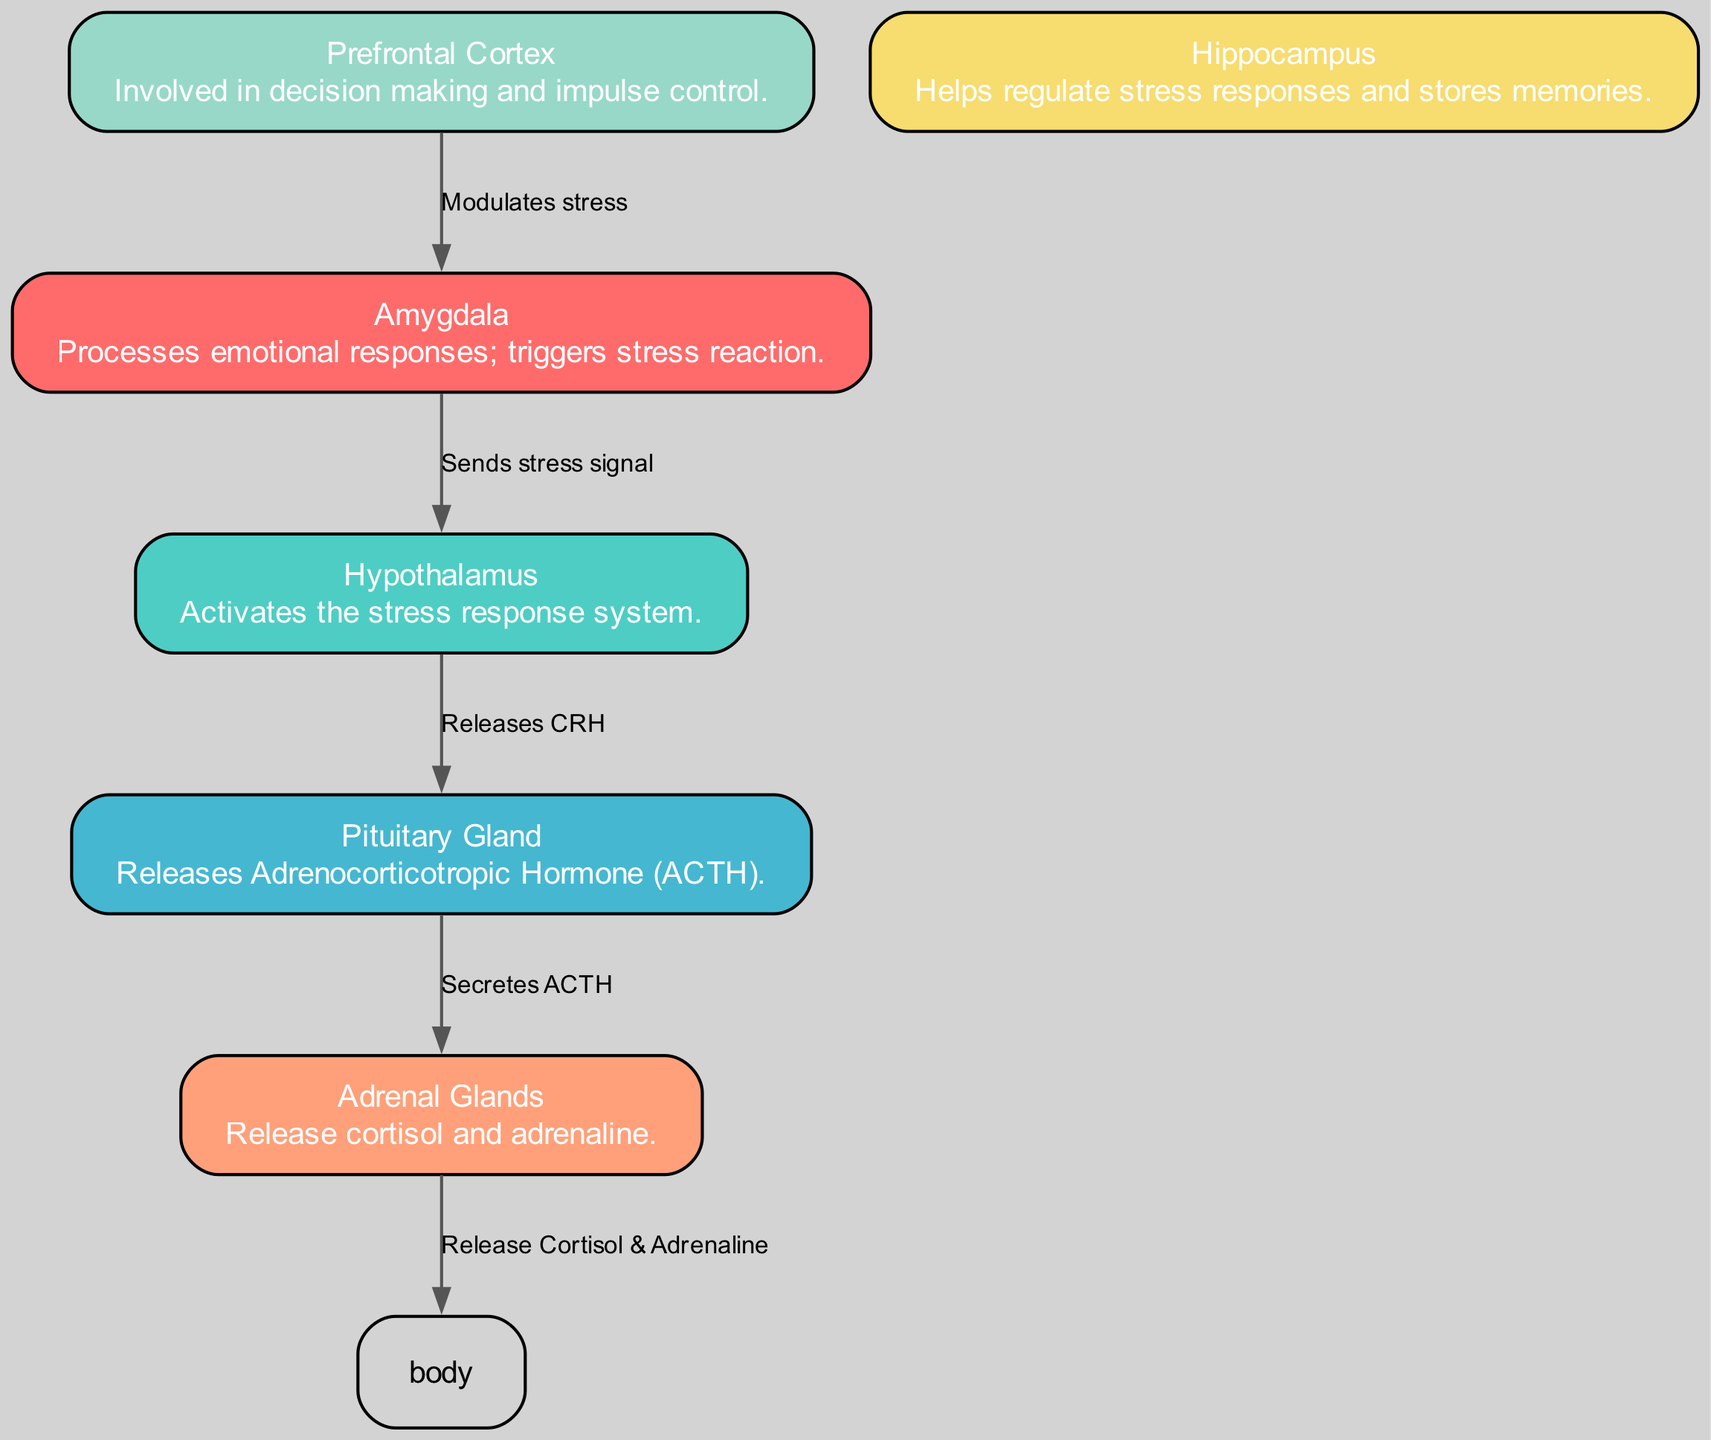What are the main brain regions involved in the stress response? The diagram lists six nodes representing brain regions: Amygdala, Hypothalamus, Pituitary Gland, Adrenal Glands, Prefrontal Cortex, and Hippocampus. These are clearly labeled in the diagram.
Answer: Amygdala, Hypothalamus, Pituitary Gland, Adrenal Glands, Prefrontal Cortex, Hippocampus Which node sends the stress signal? The edge labeled "Sends stress signal" connects the Amygdala to the Hypothalamus, indicating that the Amygdala is responsible for sending the stress signal.
Answer: Amygdala How many edges are present in the diagram? Counting the various connections (or edges) in the diagram, we find that there are five distinct edges linking the nodes together.
Answer: 5 What hormone is released by the Pituitary Gland? The label connected to the Pituitary Gland specifies that it releases Adrenocorticotropic Hormone (ACTH), making this information clear within the diagram.
Answer: Adrenocorticotropic Hormone (ACTH) What is the role of the Prefrontal Cortex in stress modulation? The edge connecting the Prefrontal Cortex to the Amygdala is labeled "Modulates stress", indicating that the Prefrontal Cortex is involved in managing or influencing stress responses.
Answer: Modulates stress What do Adrenal Glands release? The diagram shows that the Adrenal Glands release Cortisol and Adrenaline as indicated by the label on the edge connected to them.
Answer: Cortisol and Adrenaline Which brain region processes emotional responses? According to the node description in the diagram, the Amygdala is stated to process emotional responses, which directly answers the question.
Answer: Amygdala How does the Hypothalamus communicate with the Pituitary Gland? The diagram illustrates a connection where the Hypothalamus releases CRH, as represented by the edge label connecting these two nodes.
Answer: Releases CRH 